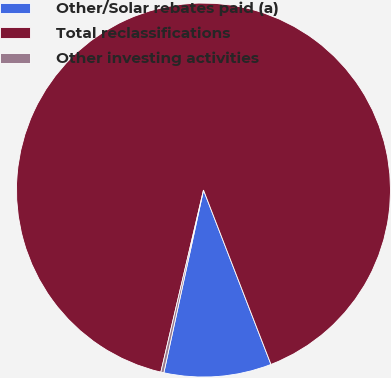Convert chart to OTSL. <chart><loc_0><loc_0><loc_500><loc_500><pie_chart><fcel>Other/Solar rebates paid (a)<fcel>Total reclassifications<fcel>Other investing activities<nl><fcel>9.28%<fcel>90.47%<fcel>0.26%<nl></chart> 